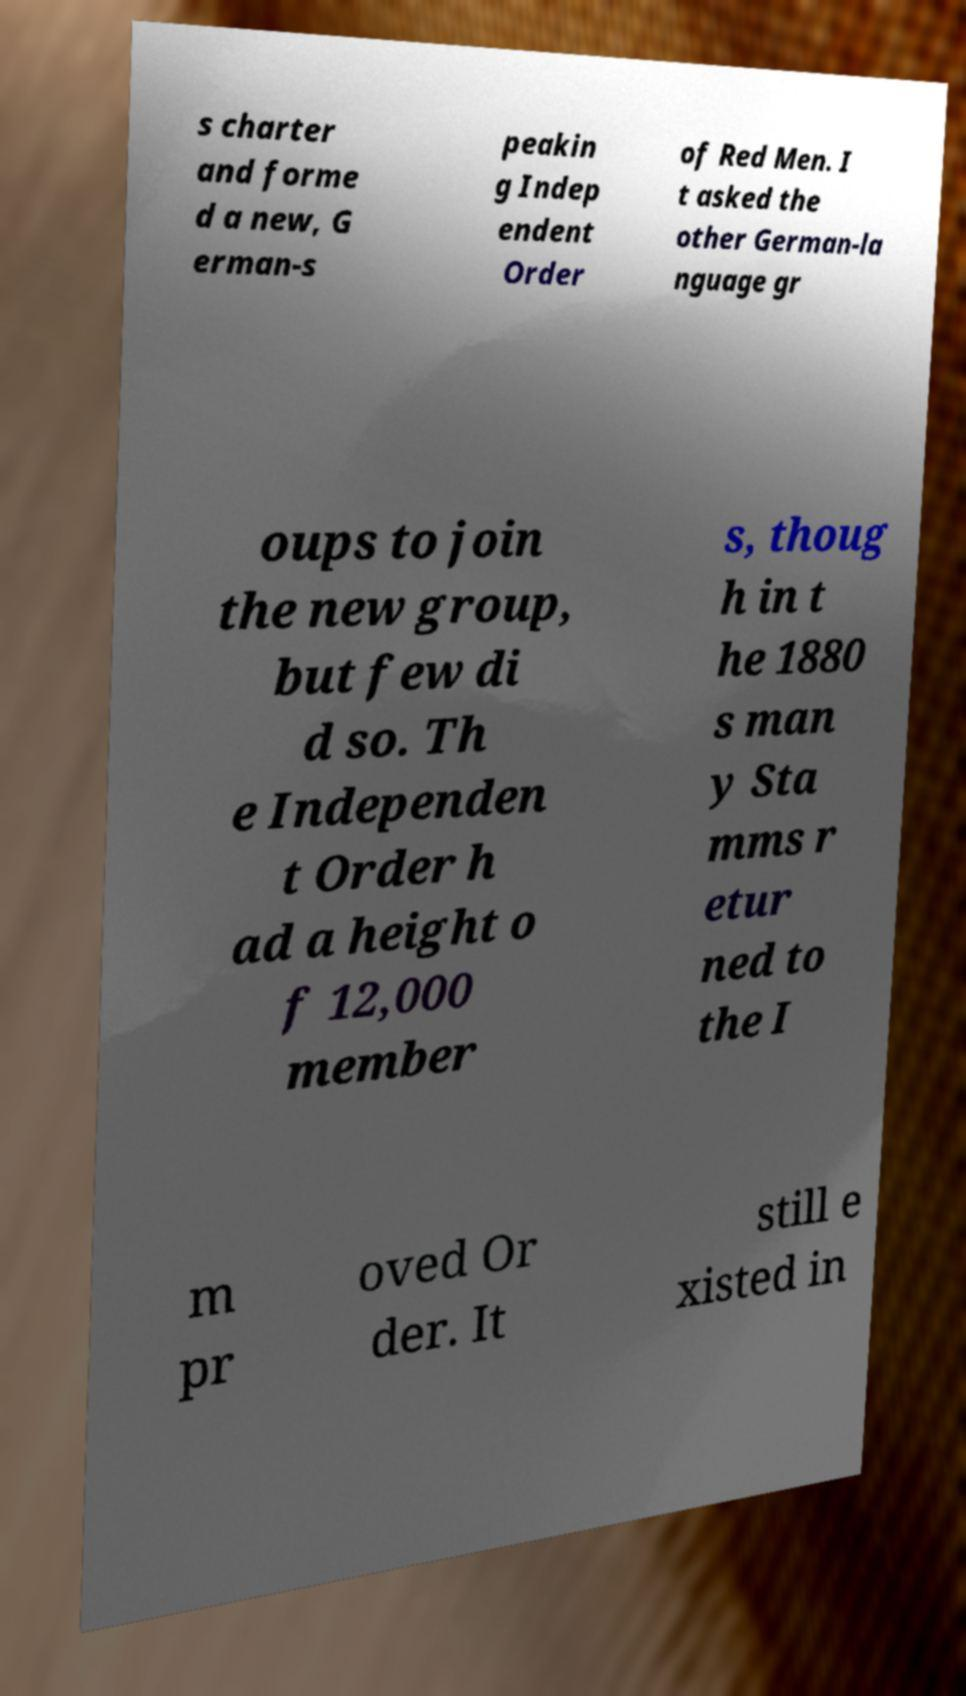Could you extract and type out the text from this image? s charter and forme d a new, G erman-s peakin g Indep endent Order of Red Men. I t asked the other German-la nguage gr oups to join the new group, but few di d so. Th e Independen t Order h ad a height o f 12,000 member s, thoug h in t he 1880 s man y Sta mms r etur ned to the I m pr oved Or der. It still e xisted in 